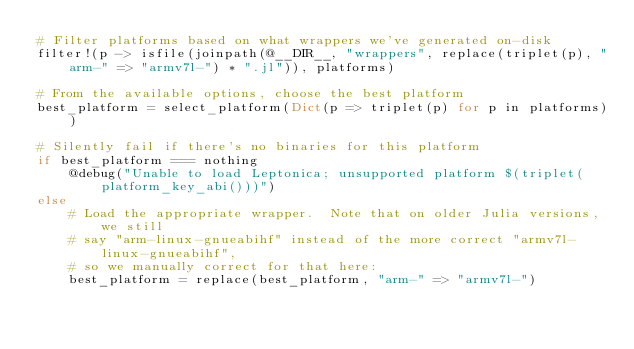<code> <loc_0><loc_0><loc_500><loc_500><_Julia_># Filter platforms based on what wrappers we've generated on-disk
filter!(p -> isfile(joinpath(@__DIR__, "wrappers", replace(triplet(p), "arm-" => "armv7l-") * ".jl")), platforms)

# From the available options, choose the best platform
best_platform = select_platform(Dict(p => triplet(p) for p in platforms))

# Silently fail if there's no binaries for this platform
if best_platform === nothing
    @debug("Unable to load Leptonica; unsupported platform $(triplet(platform_key_abi()))")
else
    # Load the appropriate wrapper.  Note that on older Julia versions, we still
    # say "arm-linux-gnueabihf" instead of the more correct "armv7l-linux-gnueabihf",
    # so we manually correct for that here:
    best_platform = replace(best_platform, "arm-" => "armv7l-")</code> 